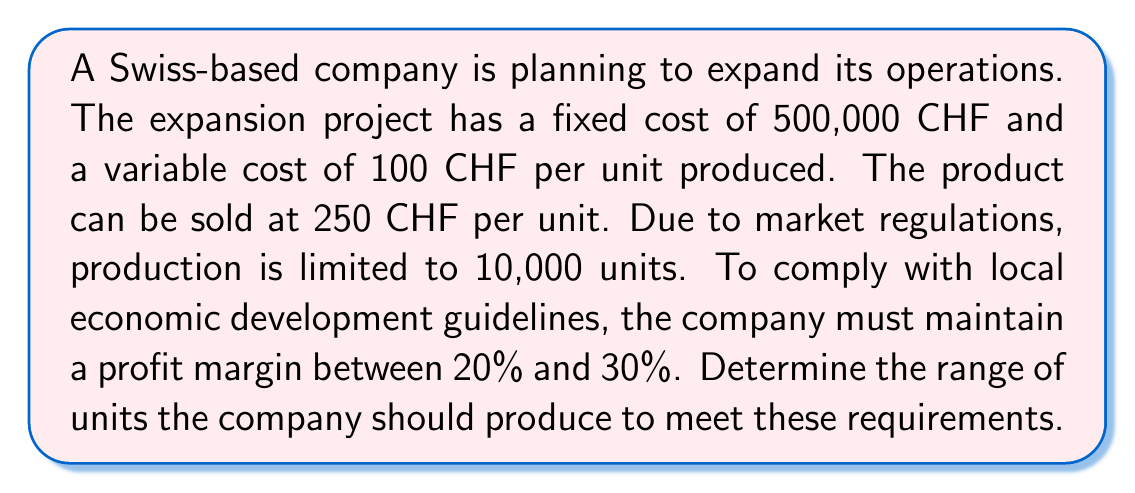Give your solution to this math problem. Let's approach this step-by-step:

1) Define variables:
   Let $x$ be the number of units produced and sold.

2) Express revenue (R), cost (C), and profit (P) functions:
   $R = 250x$
   $C = 500,000 + 100x$
   $P = R - C = 250x - (500,000 + 100x) = 150x - 500,000$

3) Express profit margin (M) as a function of x:
   $M = \frac{P}{R} = \frac{150x - 500,000}{250x}$

4) Set up inequalities for the 20% to 30% profit margin requirement:
   $0.20 \leq \frac{150x - 500,000}{250x} \leq 0.30$

5) Solve the left inequality:
   $0.20 \leq \frac{150x - 500,000}{250x}$
   $50x \leq 150x - 500,000$
   $500,000 \leq 100x$
   $5,000 \leq x$

6) Solve the right inequality:
   $\frac{150x - 500,000}{250x} \leq 0.30$
   $150x - 500,000 \leq 75x$
   $75x \leq 500,000$
   $x \leq 6,666.67$

7) Combine the results from steps 5 and 6:
   $5,000 \leq x \leq 6,666.67$

8) Consider the production limit of 10,000 units:
   This constraint is already satisfied by the upper bound found in step 7.

9) Round the results to whole units:
   $5,000 \leq x \leq 6,666$
Answer: $[5000, 6666]$ units 